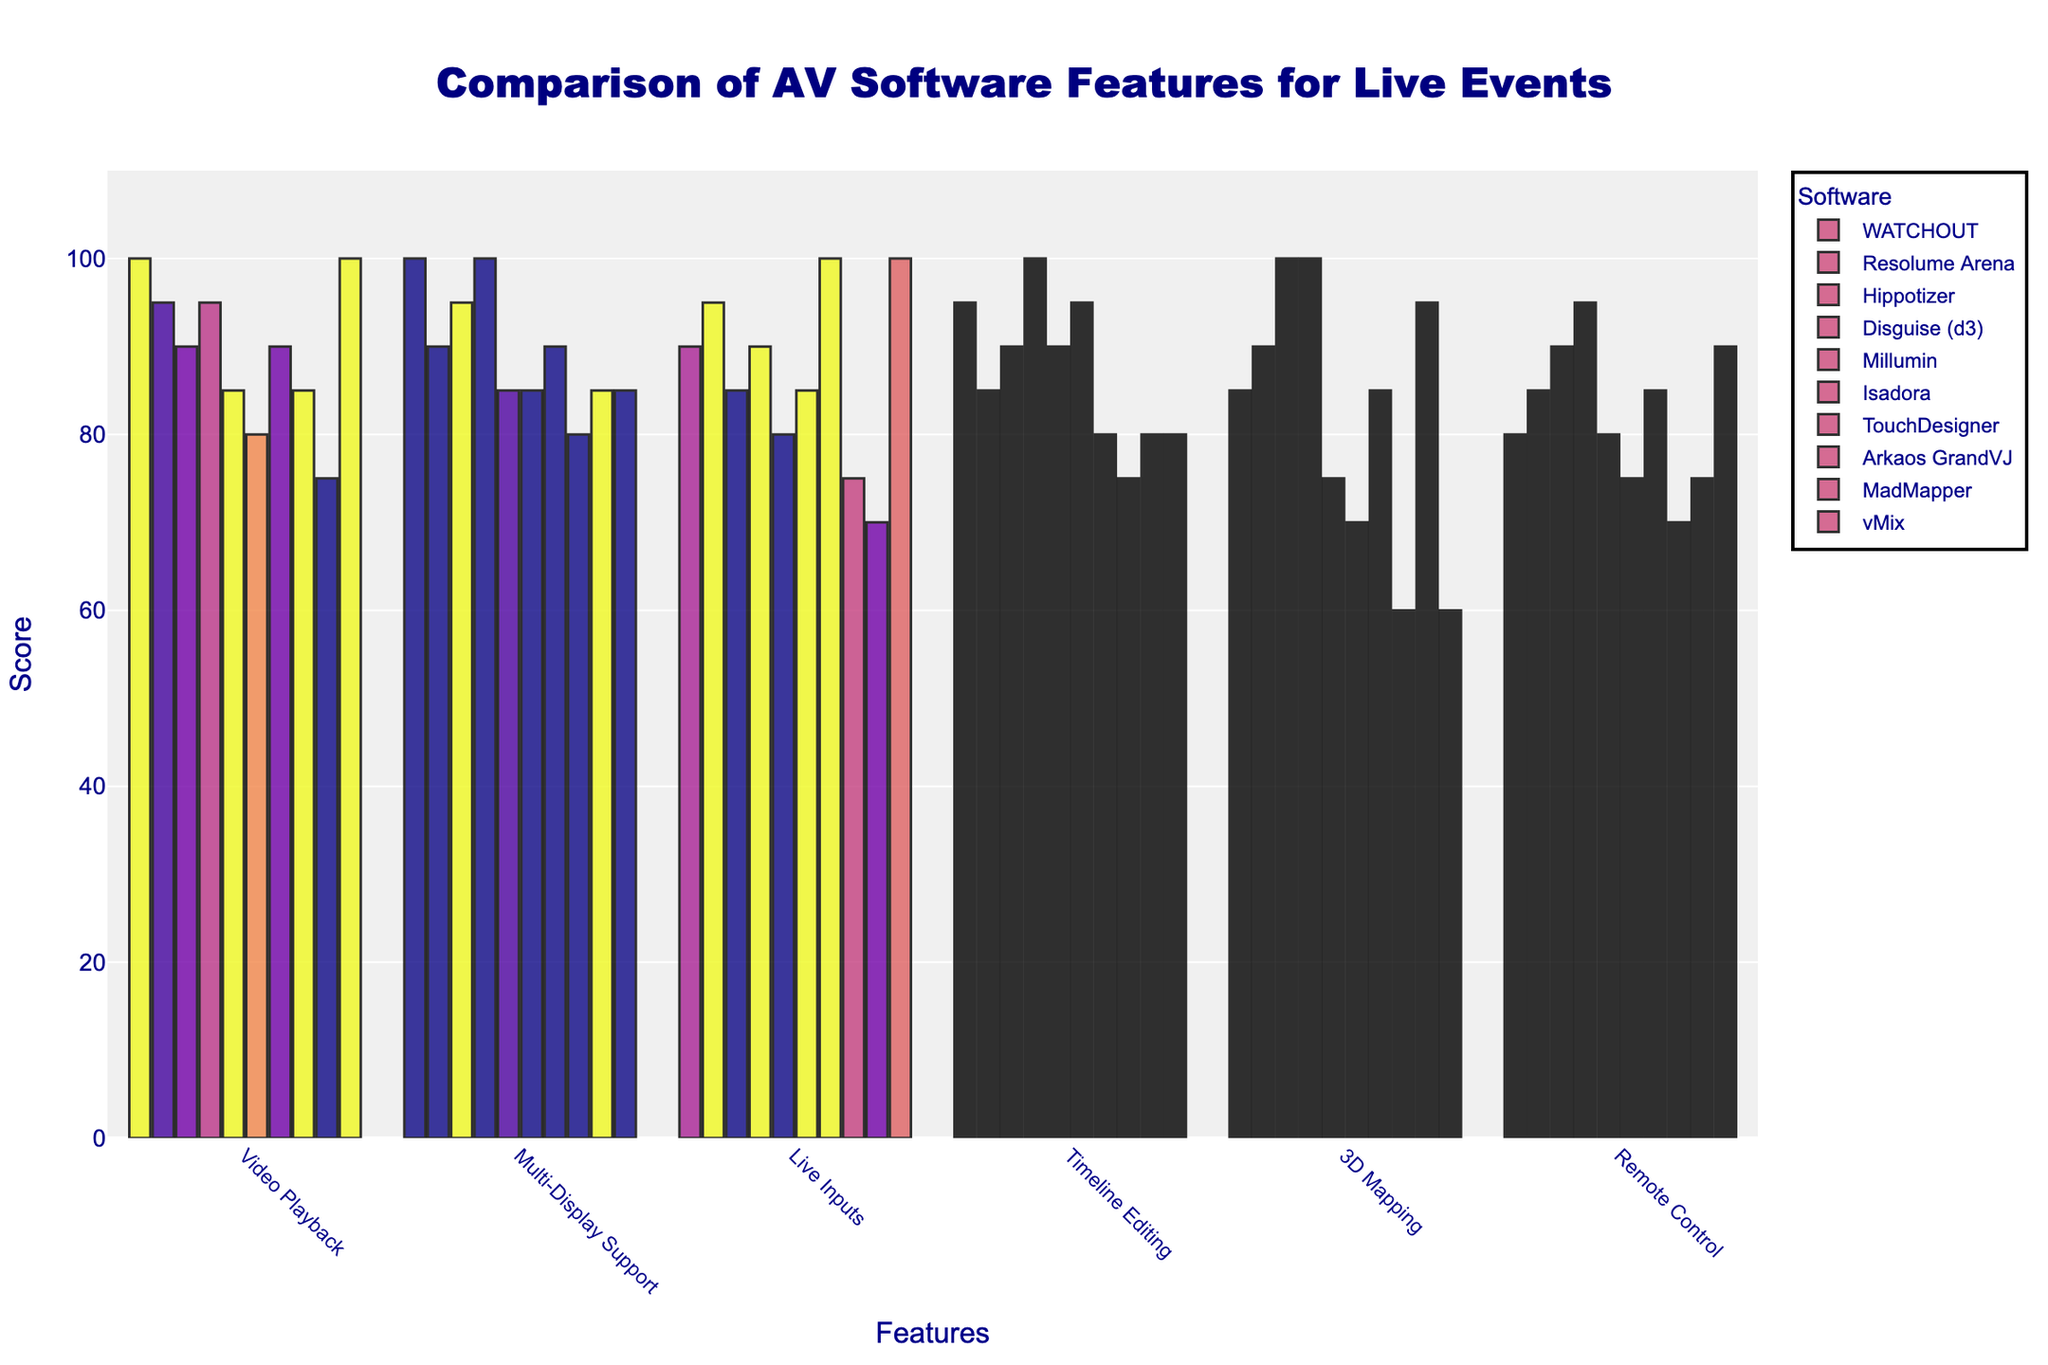What software provides the highest score for 3D Mapping? Check the bar corresponding to the 3D Mapping feature across all software. The highest score is observed under 'Disguise (d3)' with a score of 100.
Answer: Disguise (d3) Which software has the lowest score for Remote Control? Compare the bars for the Remote Control feature. 'Arkaos GrandVJ' has the shortest bar with a score of 70.
Answer: Arkaos GrandVJ How many software solutions scored 100 for Video Playback? Count the number of bars that reach the maximum height under the Video Playback feature. 'WATCHOUT' and 'vMix' both have scores of 100.
Answer: 2 What is the average score of Hippotizer across all features? Add the scores of Hippotizer: (90 + 95 + 85 + 90 + 100 + 90) = 550. Divide by the number of features (6). 550/6 = 91.67.
Answer: 91.67 Which software has better support for Live Inputs, Resolume Arena or TouchDesigner? Compare the bars under the Live Inputs feature. 'TouchDesigner' has a score of 100 whereas 'Resolume Arena' has a score of 95.
Answer: TouchDesigner Which two features does WATCHOUT score the same in? Check the bars corresponding to WATCHOUT to find identical heights. WATCHOUT scores 100 in both Video Playback and Multi-Display Support.
Answer: Video Playback and Multi-Display Support How much more expensive is Disguise (d3) compared to WATCHOUT? Subtract the price of WATCHOUT from the price of Disguise (d3). 15000 - 5000 = 10000.
Answer: 10000 USD Which features does Millumin score below 90 in? Check each feature bar for Millumin and find those below 90. Millumin scores below 90 in Video Playback (85), Multi-Display Support (85), Live Inputs (80), and 3D Mapping (75)
Answer: Video Playback, Multi-Display Support, Live Inputs, 3D Mapping What is the closest scoring feature for MadMapper compared to its Multi-Display Support score? Compare all feature scores of MadMapper and find the closest to its Multi-Display Support score (85). MadMapper's Timeline Editing score is 80 which is the closest.
Answer: Timeline Editing 